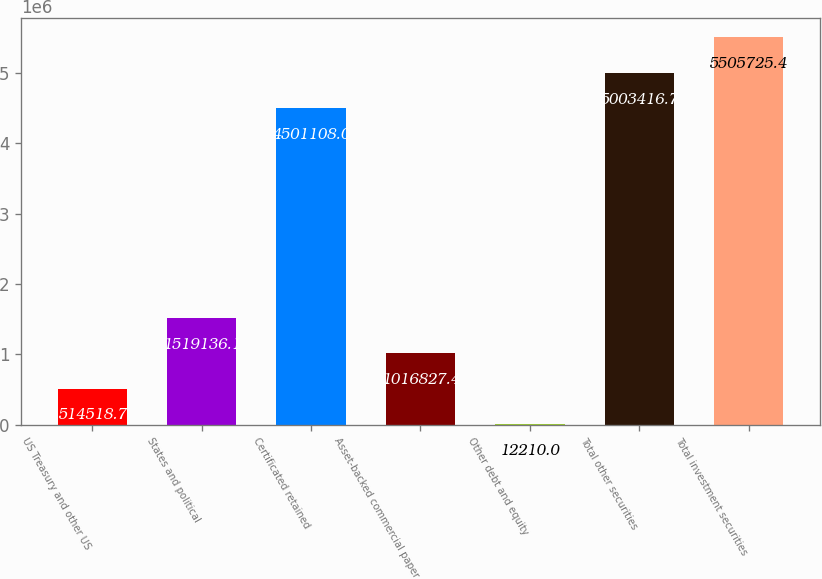Convert chart to OTSL. <chart><loc_0><loc_0><loc_500><loc_500><bar_chart><fcel>US Treasury and other US<fcel>States and political<fcel>Certificated retained<fcel>Asset-backed commercial paper<fcel>Other debt and equity<fcel>Total other securities<fcel>Total investment securities<nl><fcel>514519<fcel>1.51914e+06<fcel>4.50111e+06<fcel>1.01683e+06<fcel>12210<fcel>5.00342e+06<fcel>5.50573e+06<nl></chart> 